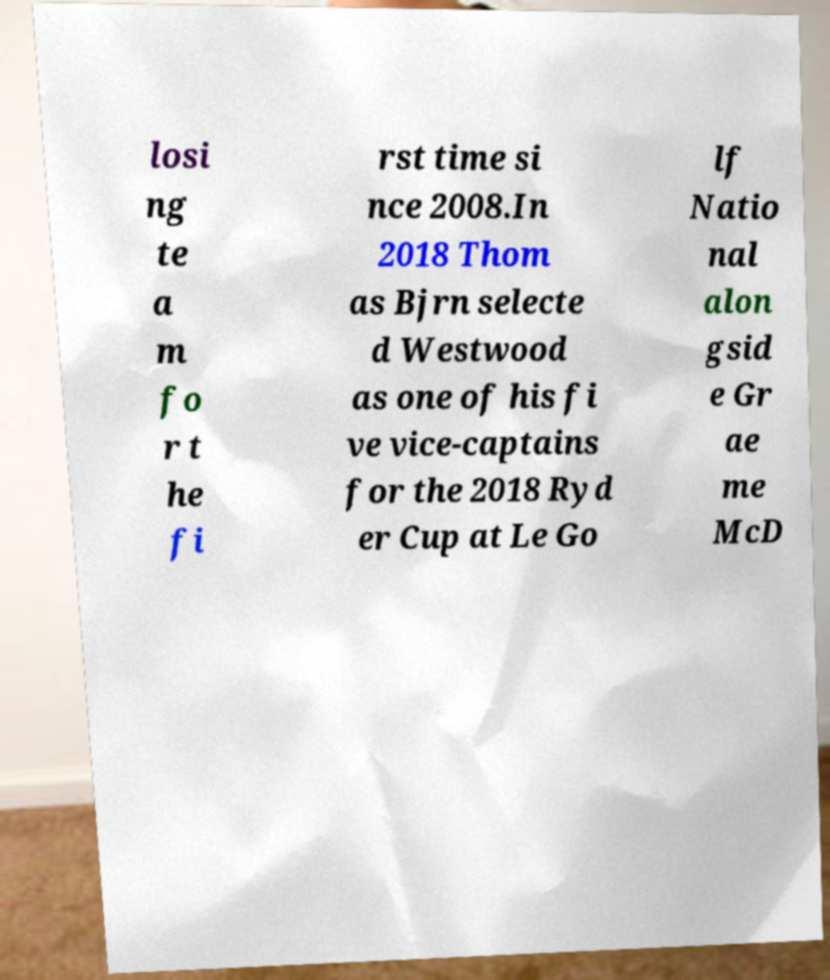Can you read and provide the text displayed in the image?This photo seems to have some interesting text. Can you extract and type it out for me? losi ng te a m fo r t he fi rst time si nce 2008.In 2018 Thom as Bjrn selecte d Westwood as one of his fi ve vice-captains for the 2018 Ryd er Cup at Le Go lf Natio nal alon gsid e Gr ae me McD 